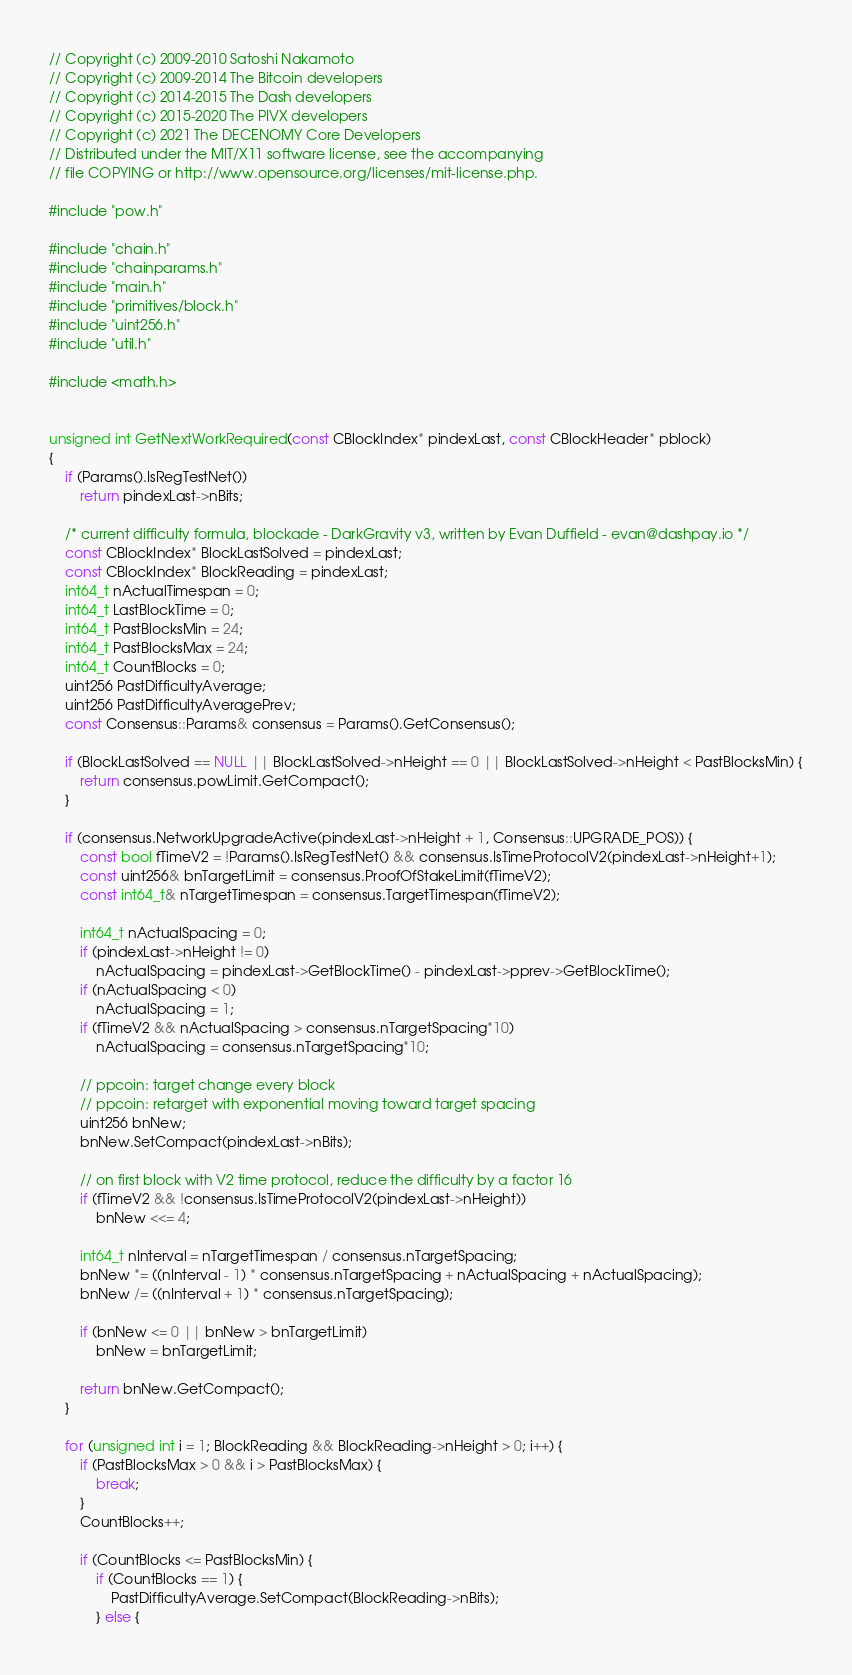<code> <loc_0><loc_0><loc_500><loc_500><_C++_>// Copyright (c) 2009-2010 Satoshi Nakamoto
// Copyright (c) 2009-2014 The Bitcoin developers
// Copyright (c) 2014-2015 The Dash developers
// Copyright (c) 2015-2020 The PIVX developers
// Copyright (c) 2021 The DECENOMY Core Developers
// Distributed under the MIT/X11 software license, see the accompanying
// file COPYING or http://www.opensource.org/licenses/mit-license.php.

#include "pow.h"

#include "chain.h"
#include "chainparams.h"
#include "main.h"
#include "primitives/block.h"
#include "uint256.h"
#include "util.h"

#include <math.h>


unsigned int GetNextWorkRequired(const CBlockIndex* pindexLast, const CBlockHeader* pblock)
{
    if (Params().IsRegTestNet())
        return pindexLast->nBits;

    /* current difficulty formula, blockade - DarkGravity v3, written by Evan Duffield - evan@dashpay.io */
    const CBlockIndex* BlockLastSolved = pindexLast;
    const CBlockIndex* BlockReading = pindexLast;
    int64_t nActualTimespan = 0;
    int64_t LastBlockTime = 0;
    int64_t PastBlocksMin = 24;
    int64_t PastBlocksMax = 24;
    int64_t CountBlocks = 0;
    uint256 PastDifficultyAverage;
    uint256 PastDifficultyAveragePrev;
    const Consensus::Params& consensus = Params().GetConsensus();

    if (BlockLastSolved == NULL || BlockLastSolved->nHeight == 0 || BlockLastSolved->nHeight < PastBlocksMin) {
        return consensus.powLimit.GetCompact();
    }

    if (consensus.NetworkUpgradeActive(pindexLast->nHeight + 1, Consensus::UPGRADE_POS)) {
        const bool fTimeV2 = !Params().IsRegTestNet() && consensus.IsTimeProtocolV2(pindexLast->nHeight+1);
        const uint256& bnTargetLimit = consensus.ProofOfStakeLimit(fTimeV2);
        const int64_t& nTargetTimespan = consensus.TargetTimespan(fTimeV2);

        int64_t nActualSpacing = 0;
        if (pindexLast->nHeight != 0)
            nActualSpacing = pindexLast->GetBlockTime() - pindexLast->pprev->GetBlockTime();
        if (nActualSpacing < 0)
            nActualSpacing = 1;
        if (fTimeV2 && nActualSpacing > consensus.nTargetSpacing*10)
            nActualSpacing = consensus.nTargetSpacing*10;

        // ppcoin: target change every block
        // ppcoin: retarget with exponential moving toward target spacing
        uint256 bnNew;
        bnNew.SetCompact(pindexLast->nBits);

        // on first block with V2 time protocol, reduce the difficulty by a factor 16
        if (fTimeV2 && !consensus.IsTimeProtocolV2(pindexLast->nHeight))
            bnNew <<= 4;

        int64_t nInterval = nTargetTimespan / consensus.nTargetSpacing;
        bnNew *= ((nInterval - 1) * consensus.nTargetSpacing + nActualSpacing + nActualSpacing);
        bnNew /= ((nInterval + 1) * consensus.nTargetSpacing);

        if (bnNew <= 0 || bnNew > bnTargetLimit)
            bnNew = bnTargetLimit;

        return bnNew.GetCompact();
    }

    for (unsigned int i = 1; BlockReading && BlockReading->nHeight > 0; i++) {
        if (PastBlocksMax > 0 && i > PastBlocksMax) {
            break;
        }
        CountBlocks++;

        if (CountBlocks <= PastBlocksMin) {
            if (CountBlocks == 1) {
                PastDifficultyAverage.SetCompact(BlockReading->nBits);
            } else {</code> 